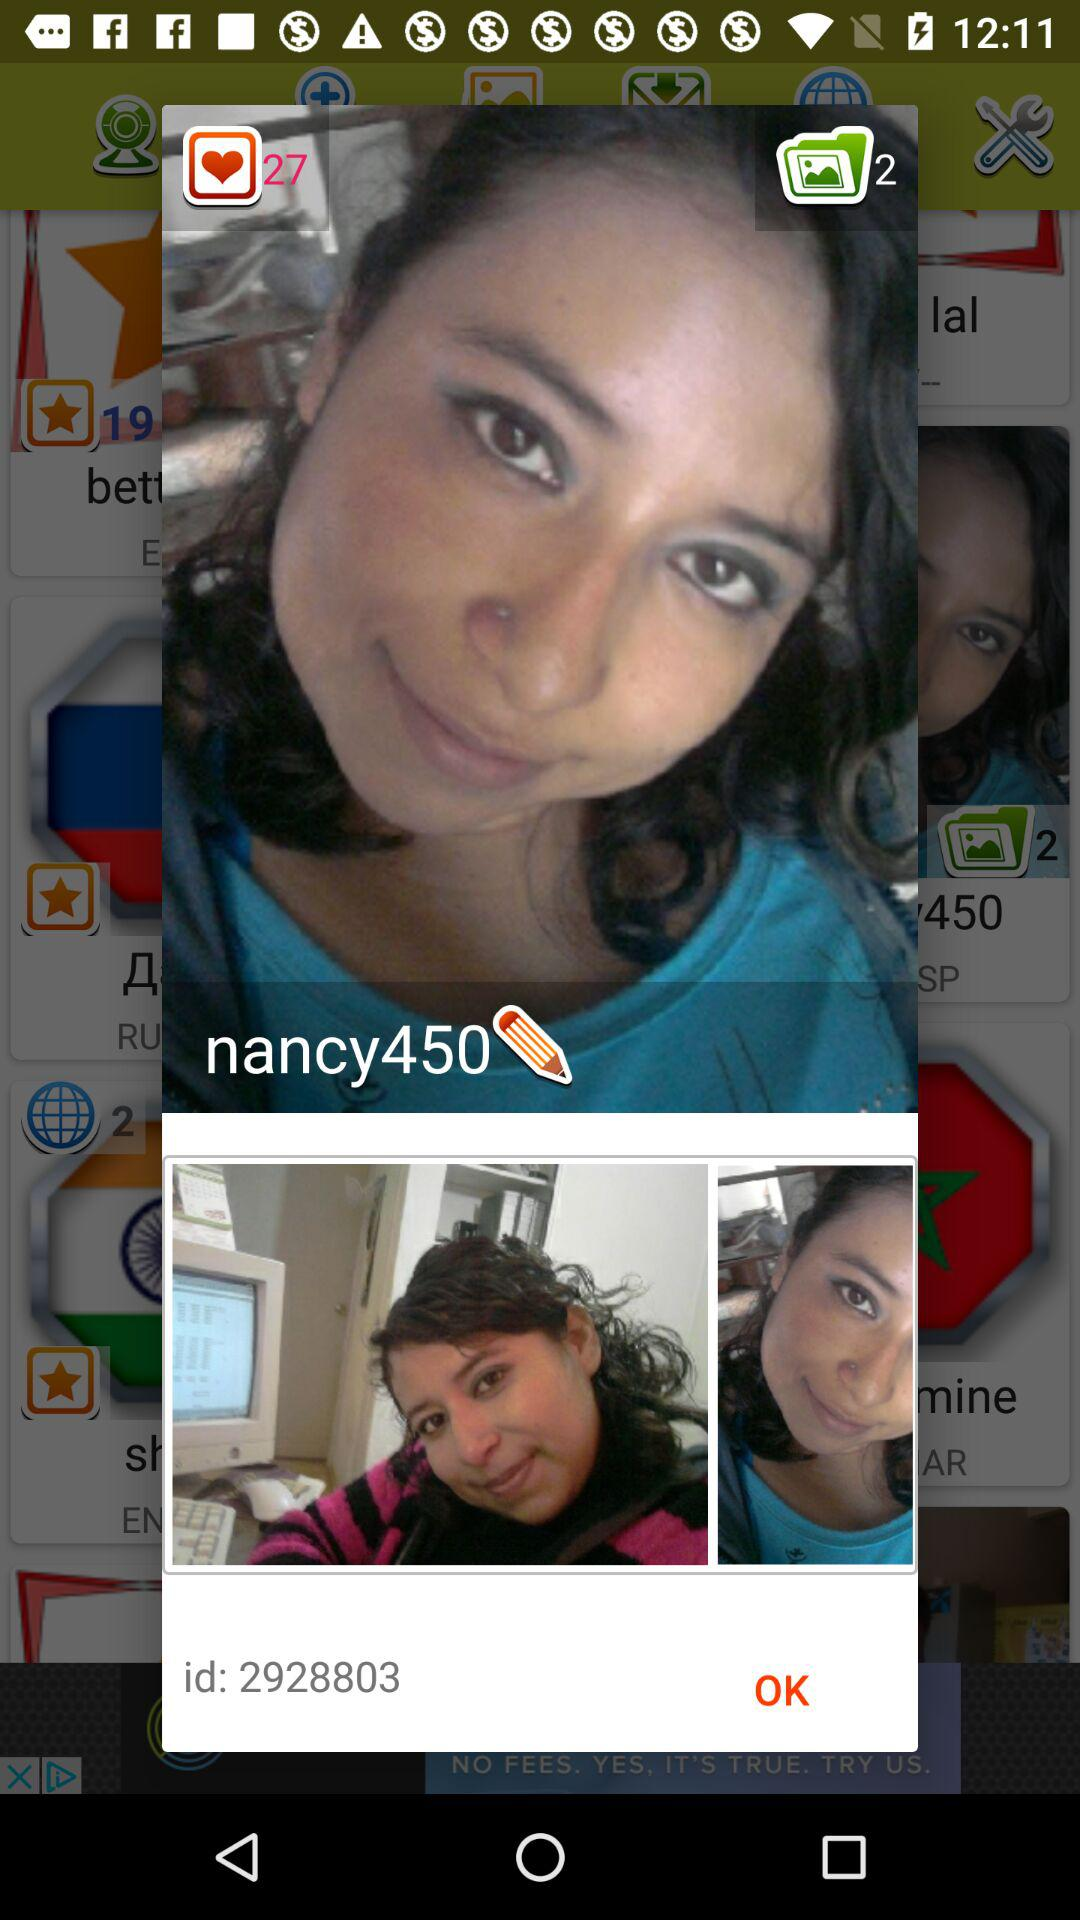What's the username? The username is "nancy450". 